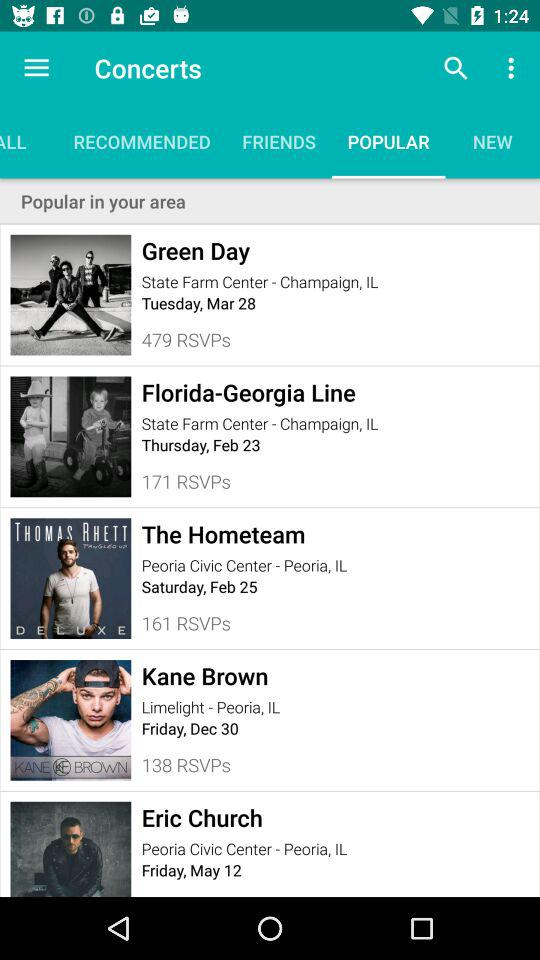What is the venue of "The Hometeam" concert? The venue of "The Hometeam" concert is the "Peoria Civic Center" in Peoria, IL. 